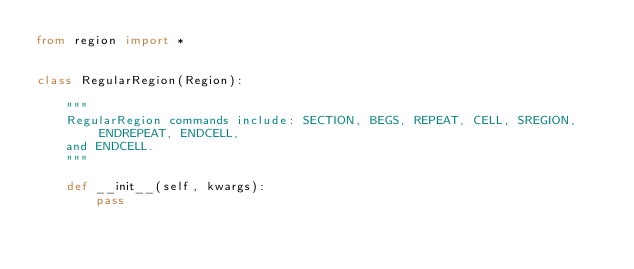Convert code to text. <code><loc_0><loc_0><loc_500><loc_500><_Python_>from region import *


class RegularRegion(Region):

    """
    RegularRegion commands include: SECTION, BEGS, REPEAT, CELL, SREGION, ENDREPEAT, ENDCELL,
    and ENDCELL.
    """

    def __init__(self, kwargs):
        pass
</code> 